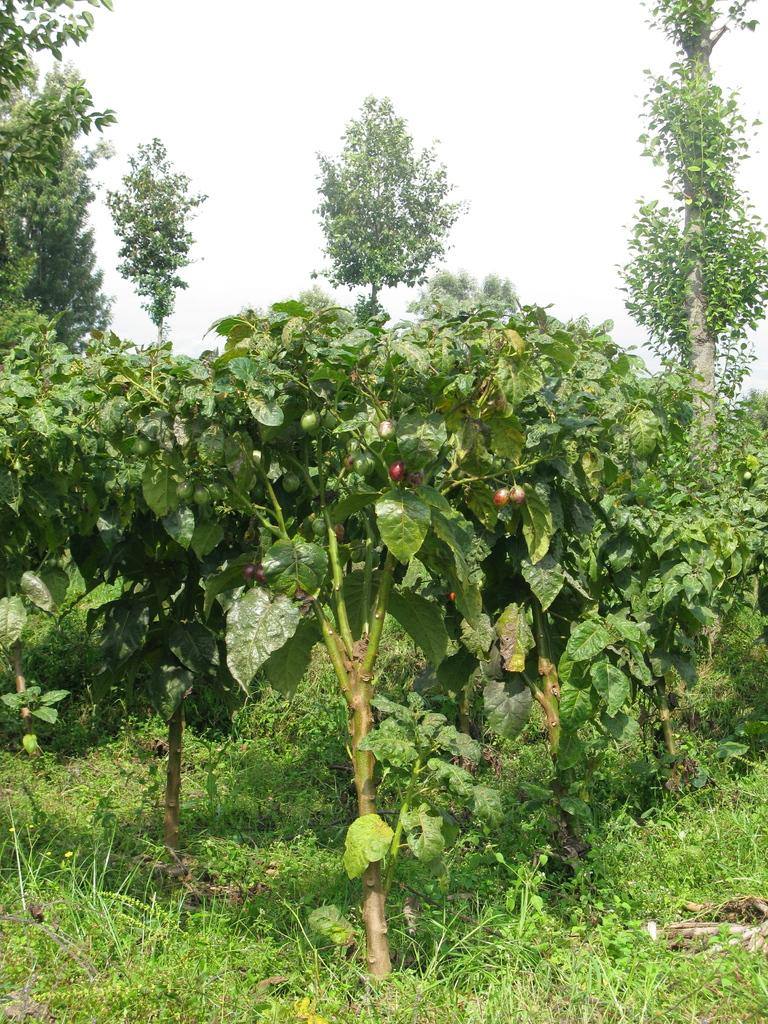What type of vegetation is present in the image? There is grass and trees in the image. What else can be seen in the image besides vegetation? There are fruits in the image. How many socks are hanging on the tree in the image? There are no socks present in the image; it features grass, trees, and fruits. 